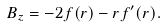Convert formula to latex. <formula><loc_0><loc_0><loc_500><loc_500>B _ { z } = - 2 f ( r ) - r f ^ { \prime } ( r ) .</formula> 